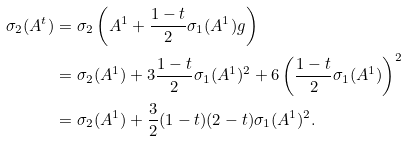<formula> <loc_0><loc_0><loc_500><loc_500>\sigma _ { 2 } ( A ^ { t } ) & = \sigma _ { 2 } \left ( A ^ { 1 } + \frac { 1 - t } { 2 } \sigma _ { 1 } ( A ^ { 1 } ) g \right ) \\ & = \sigma _ { 2 } ( A ^ { 1 } ) + 3 \frac { 1 - t } { 2 } \sigma _ { 1 } ( A ^ { 1 } ) ^ { 2 } + 6 \left ( \frac { 1 - t } { 2 } \sigma _ { 1 } ( A ^ { 1 } ) \right ) ^ { 2 } \\ & = \sigma _ { 2 } ( A ^ { 1 } ) + \frac { 3 } { 2 } ( 1 - t ) ( 2 - t ) \sigma _ { 1 } ( A ^ { 1 } ) ^ { 2 } .</formula> 